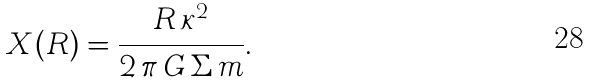Convert formula to latex. <formula><loc_0><loc_0><loc_500><loc_500>X ( R ) = \frac { R \, \kappa ^ { 2 } } { 2 \, \pi \, G \, \Sigma \, m } .</formula> 